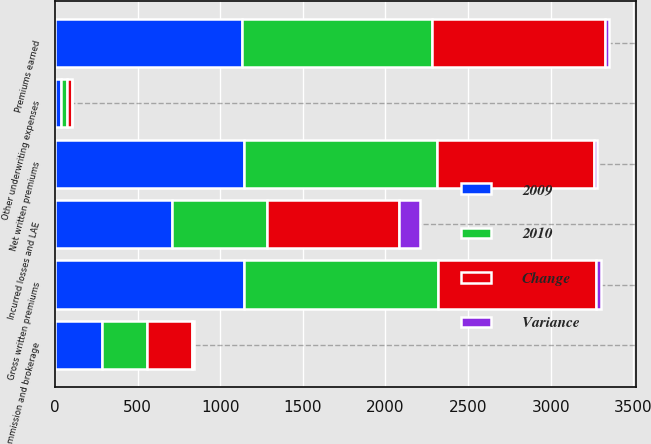<chart> <loc_0><loc_0><loc_500><loc_500><stacked_bar_chart><ecel><fcel>Gross written premiums<fcel>Net written premiums<fcel>Premiums earned<fcel>Incurred losses and LAE<fcel>Commission and brokerage<fcel>Other underwriting expenses<nl><fcel>2009<fcel>1143.7<fcel>1145.2<fcel>1129.3<fcel>706.3<fcel>284.6<fcel>33.9<nl><fcel>2010<fcel>1172.3<fcel>1167.2<fcel>1150.3<fcel>574.8<fcel>272.2<fcel>36.2<nl><fcel>Change<fcel>957.9<fcel>948.8<fcel>1050.3<fcel>798.2<fcel>273.3<fcel>32.2<nl><fcel>Variance<fcel>28.6<fcel>22.1<fcel>21<fcel>131.6<fcel>12.4<fcel>2.2<nl></chart> 